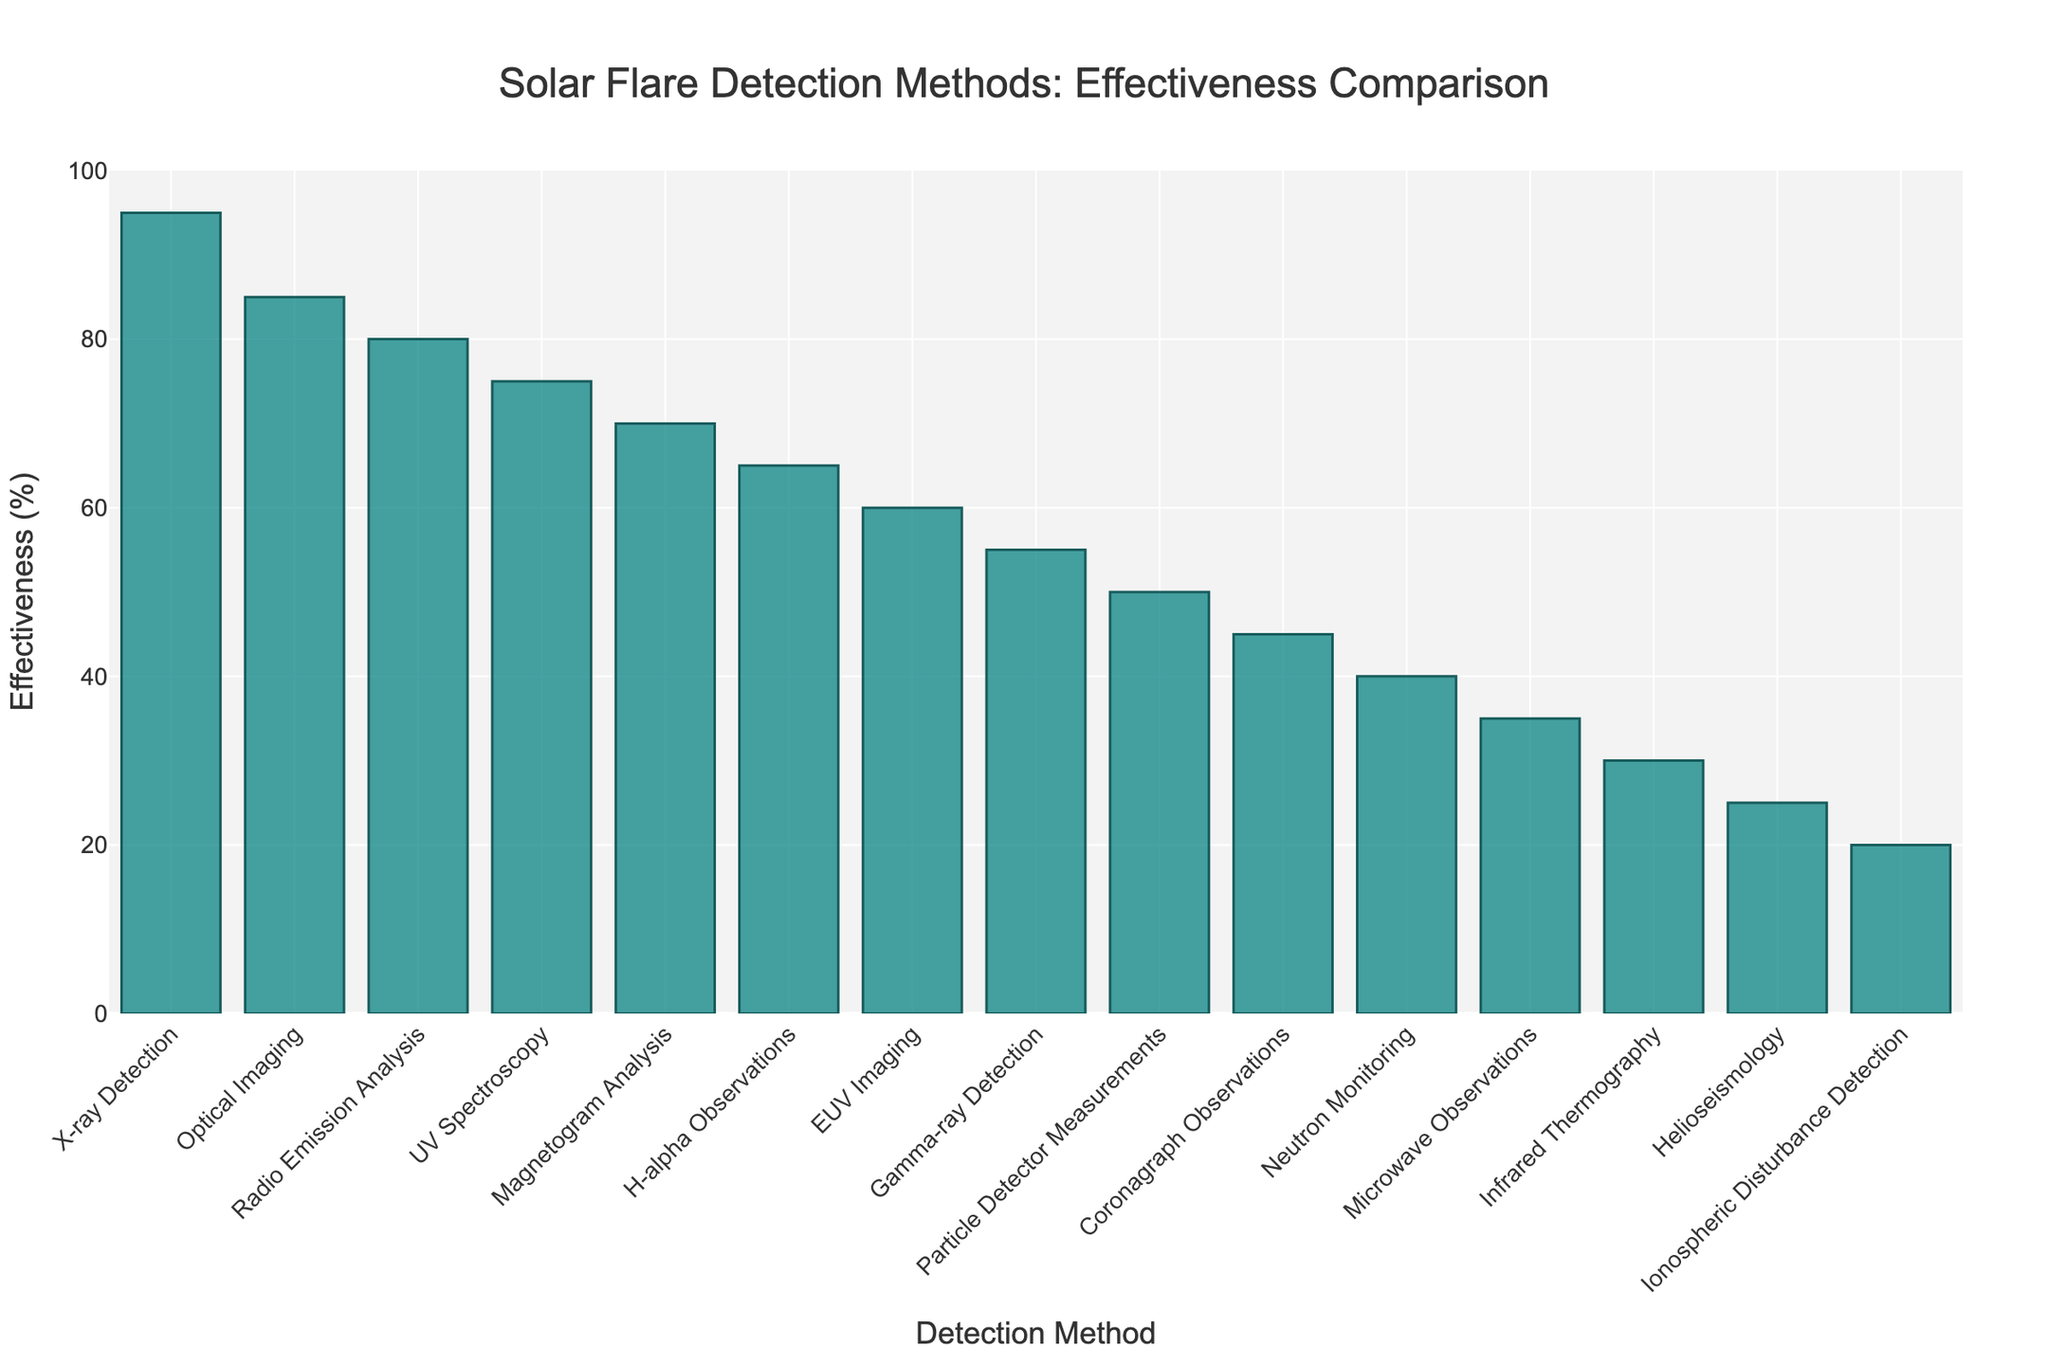Which method is the most effective for detecting solar flares? The highest bar in the chart represents the most effective method, which is 'X-ray Detection' with an effectiveness of 95%.
Answer: X-ray Detection Which detection method has the least effectiveness? The shortest bar in the chart represents the least effective method, which is 'Ionospheric Disturbance Detection' with an effectiveness of 20%.
Answer: Ionospheric Disturbance Detection How much more effective is 'UV Spectroscopy' compared to 'Helioseismology'? Find the effectiveness of both methods: 'UV Spectroscopy' (75%) and 'Helioseismology' (25%). Subtract the effectiveness of 'Helioseismology' from 'UV Spectroscopy': 75% - 25% = 50%.
Answer: 50% Which two detection methods have an effectiveness within 5% of each other? The two methods are 'Optical Imaging' with 85% and 'Radio Emission Analysis' with 80%, because 85% - 80% = 5%.
Answer: Optical Imaging and Radio Emission Analysis What is the combined effectiveness of 'Gamma-ray Detection' and 'Microwave Observations'? Add the effectiveness of 'Gamma-ray Detection' (55%) and 'Microwave Observations' (35%): 55% + 35% = 90%.
Answer: 90% Which method's effectiveness is closest to the median effectiveness of all listed methods? First, list the effectiveness of all methods in numerical order: 20%, 25%, 30%, 35%, 40%, 45%, 50%, 55%, 60%, 65%, 70%, 75%, 80%, 85%, 95%. The median is the middle value: 55%. 'Gamma-ray Detection' has an effectiveness of 55%.
Answer: Gamma-ray Detection Between 'Magnetogram Analysis' and 'EUV Imaging', which one is more effective and by how much? 'Magnetogram Analysis' has an effectiveness of 70%, and 'EUV Imaging' has an effectiveness of 60%. Subtract the effectiveness of 'EUV Imaging' from 'Magnetogram Analysis': 70% - 60% = 10%.
Answer: Magnetogram Analysis by 10% What is the average effectiveness of the top three methods? The top three methods are 'X-ray Detection' (95%), 'Optical Imaging' (85%), and 'Radio Emission Analysis' (80%). Add their effectiveness and divide by 3: (95% + 85% + 80%) / 3 = 86.67%.
Answer: 86.67% How many methods have an effectiveness greater than 65%? Count the number of bars with effectiveness greater than 65%: 'X-ray Detection', 'Optical Imaging', 'Radio Emission Analysis', 'UV Spectroscopy', and 'Magnetogram Analysis'. There are 5 methods.
Answer: 5 Which detection method's bar is just above the midpoint (50%) of the y-axis? Identify the method(s) with effectiveness closest to but above 50% on the y-axis: 'Gamma-ray Detection' has an effectiveness of 55%, which is just above the midpoint of 50%.
Answer: Gamma-ray Detection 